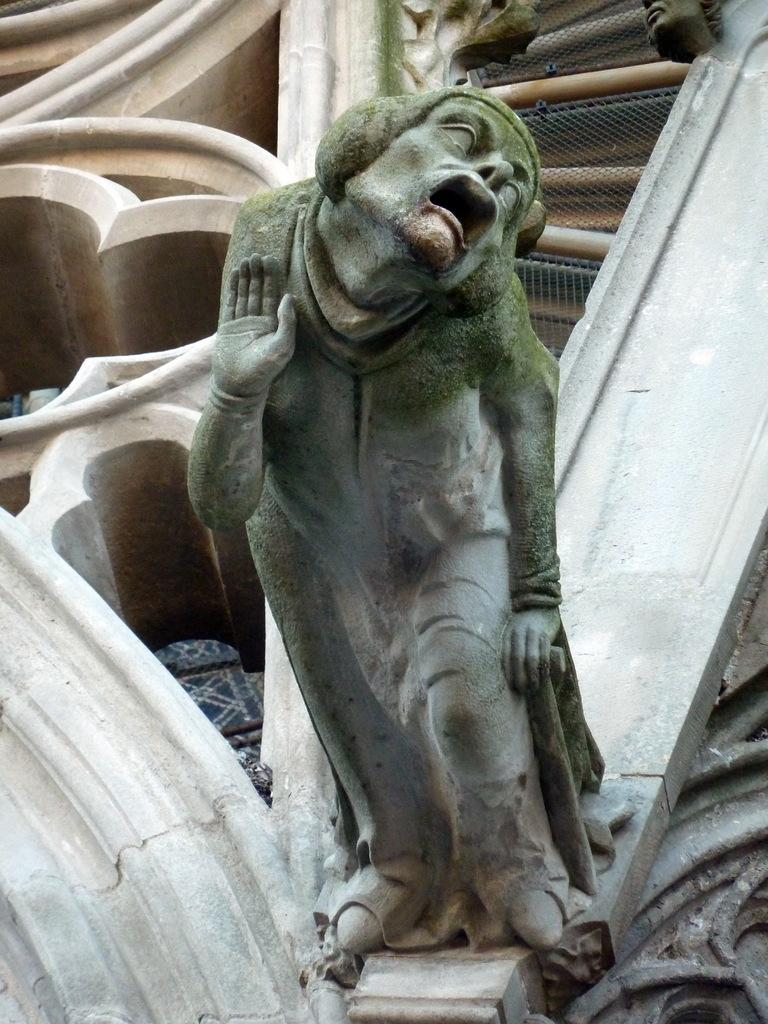What is the main subject in the image? There is a statue in the image. What is located at the back of the image? There is a wall at the back of the image. What can be seen on the wall? There are sculptures on the wall. What type of barrier is present in the image? There is a fence in the image. How many feet tall is the statue in the image? The provided facts do not mention the height of the statue, so it cannot be determined from the image. 